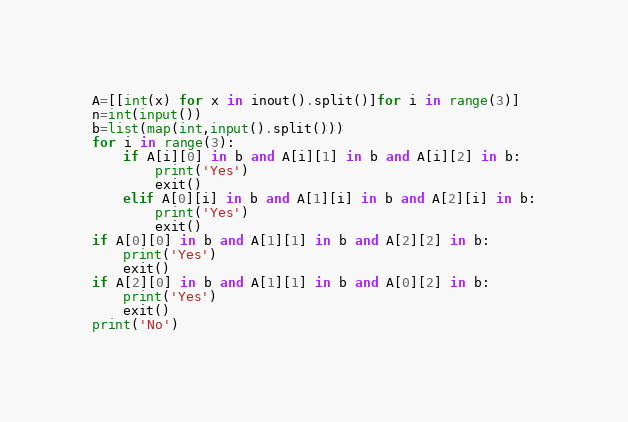Convert code to text. <code><loc_0><loc_0><loc_500><loc_500><_Python_>A=[[int(x) for x in inout().split()]for i in range(3)]
n=int(input())
b=list(map(int,input().split()))
for i in range(3):
    if A[i][0] in b and A[i][1] in b and A[i][2] in b:
        print('Yes')
        exit()
    elif A[0][i] in b and A[1][i] in b and A[2][i] in b:
        print('Yes')
        exit()
if A[0][0] in b and A[1][1] in b and A[2][2] in b:
    print('Yes')
    exit()
if A[2][0] in b and A[1][1] in b and A[0][2] in b:
    print('Yes')
    exit()
print('No')</code> 